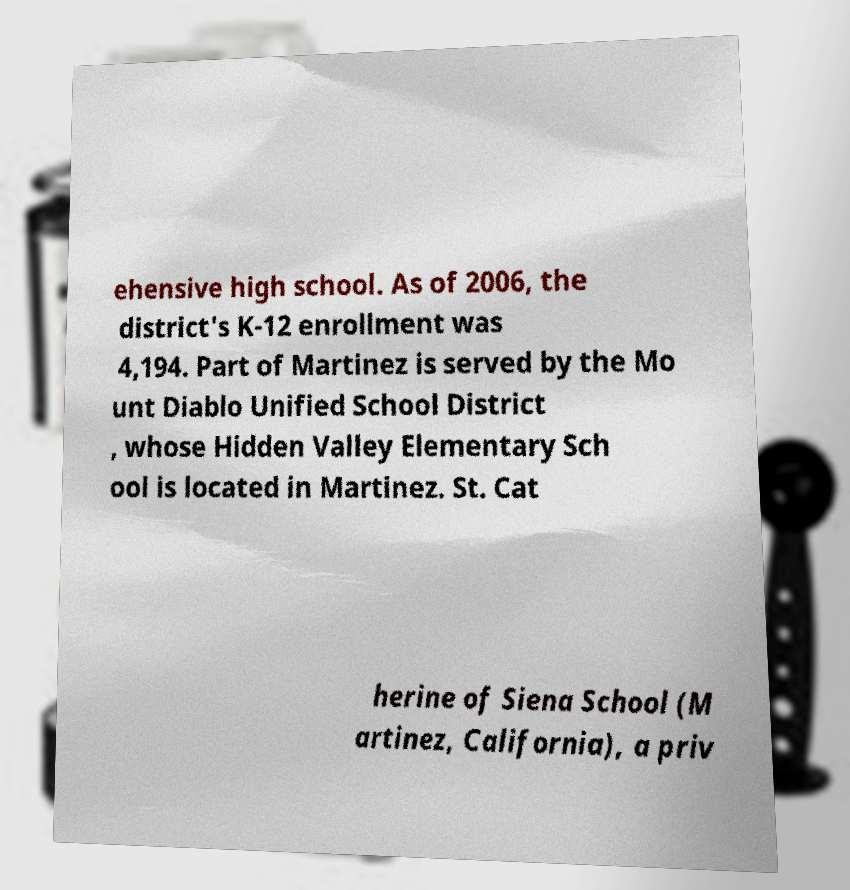Can you accurately transcribe the text from the provided image for me? ehensive high school. As of 2006, the district's K-12 enrollment was 4,194. Part of Martinez is served by the Mo unt Diablo Unified School District , whose Hidden Valley Elementary Sch ool is located in Martinez. St. Cat herine of Siena School (M artinez, California), a priv 